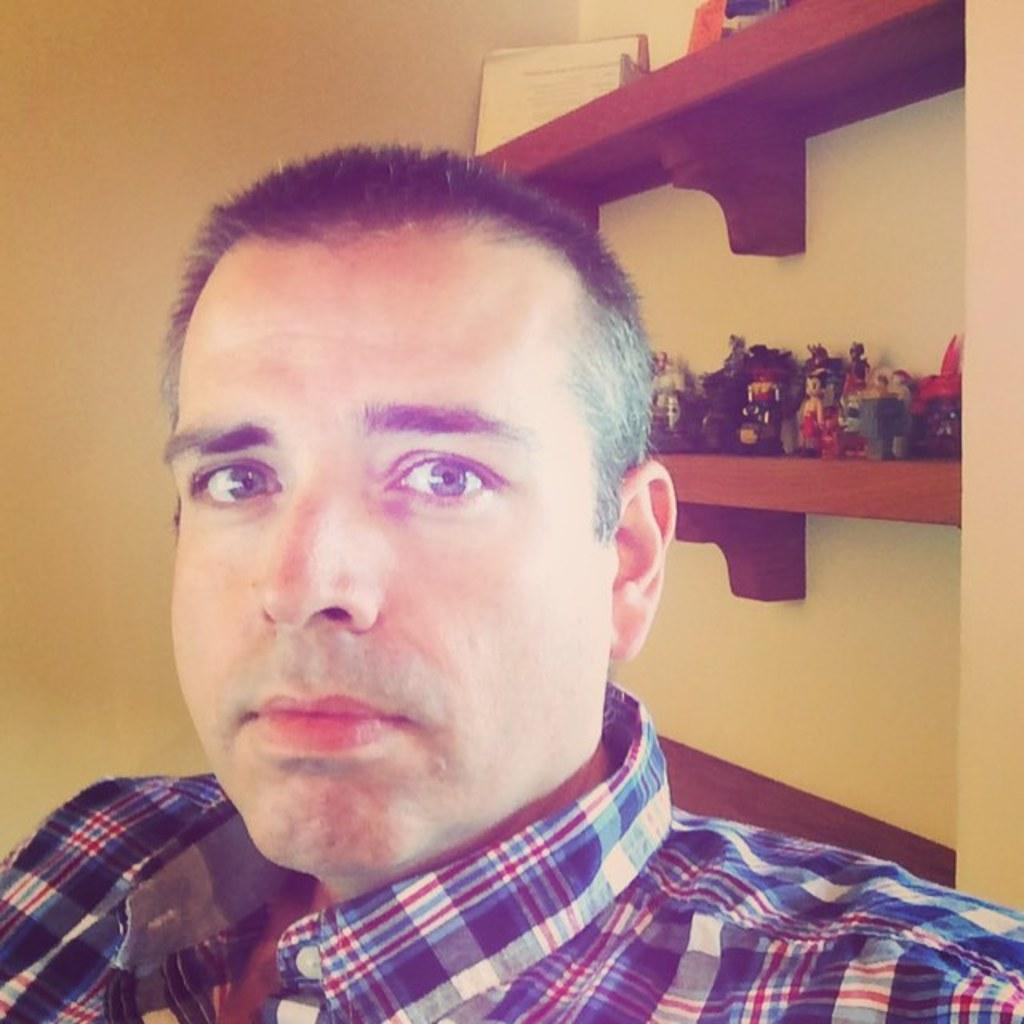Who or what is in the center of the image? There is a person in the center of the image. What can be seen in the background of the image? There is a wall, racks, and toys in the background of the image. What type of pan is being used to support the person in the image? There is no pan present in the image, and the person is not being supported by any object. 